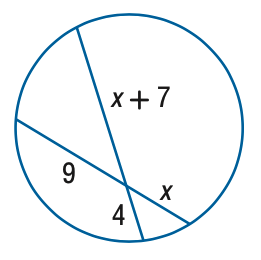Answer the mathemtical geometry problem and directly provide the correct option letter.
Question: Find x.
Choices: A: 4.6 B: 5.6 C: 6.6 D: 7.6 B 